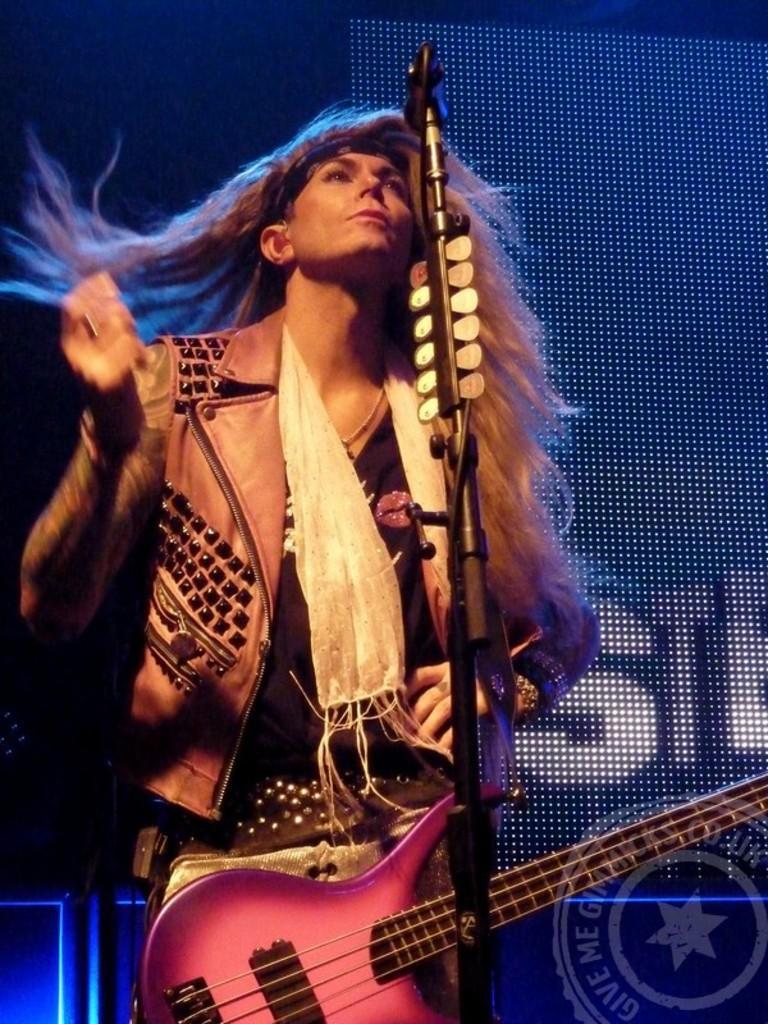How would you summarize this image in a sentence or two? A person is standing and playing the guitar. He wear a coat. 